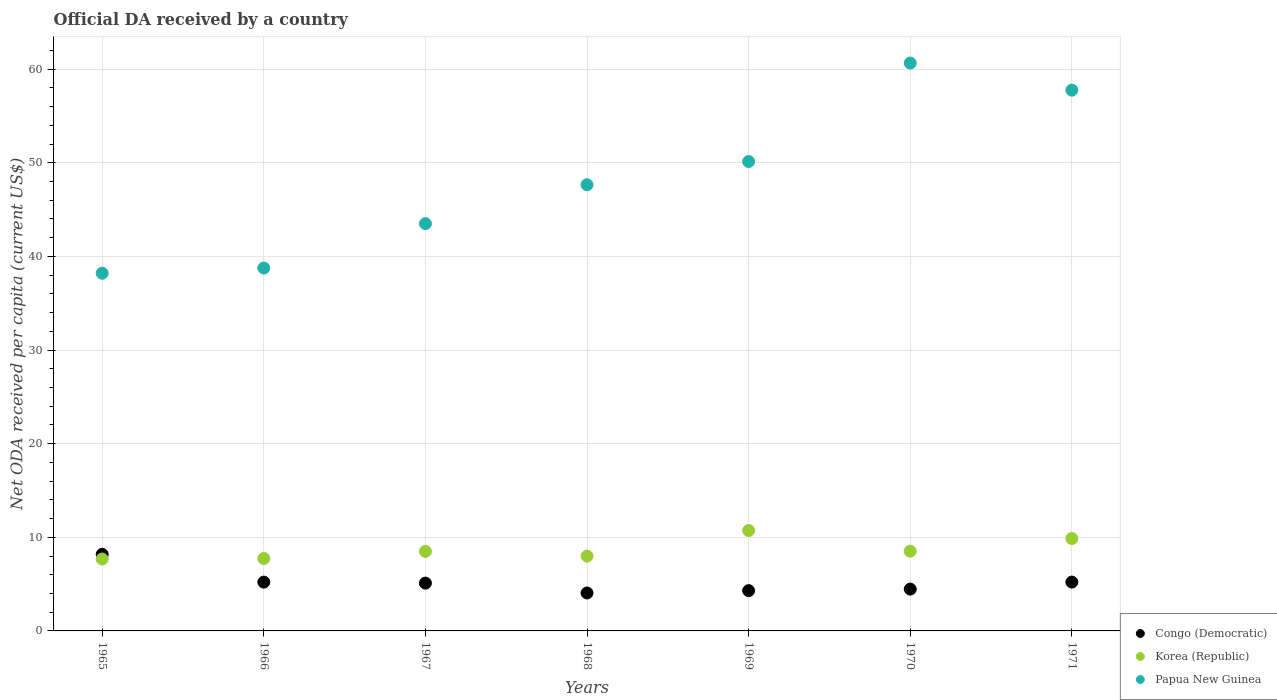How many different coloured dotlines are there?
Provide a succinct answer. 3. Is the number of dotlines equal to the number of legend labels?
Keep it short and to the point. Yes. What is the ODA received in in Congo (Democratic) in 1970?
Make the answer very short. 4.47. Across all years, what is the maximum ODA received in in Papua New Guinea?
Offer a very short reply. 60.65. Across all years, what is the minimum ODA received in in Congo (Democratic)?
Give a very brief answer. 4.05. In which year was the ODA received in in Korea (Republic) maximum?
Give a very brief answer. 1969. In which year was the ODA received in in Congo (Democratic) minimum?
Make the answer very short. 1968. What is the total ODA received in in Congo (Democratic) in the graph?
Your response must be concise. 36.54. What is the difference between the ODA received in in Congo (Democratic) in 1965 and that in 1969?
Offer a terse response. 3.88. What is the difference between the ODA received in in Papua New Guinea in 1971 and the ODA received in in Congo (Democratic) in 1970?
Your answer should be very brief. 53.29. What is the average ODA received in in Korea (Republic) per year?
Keep it short and to the point. 8.72. In the year 1968, what is the difference between the ODA received in in Papua New Guinea and ODA received in in Korea (Republic)?
Offer a very short reply. 39.66. In how many years, is the ODA received in in Papua New Guinea greater than 60 US$?
Your answer should be very brief. 1. What is the ratio of the ODA received in in Korea (Republic) in 1968 to that in 1969?
Your answer should be compact. 0.75. Is the ODA received in in Korea (Republic) in 1965 less than that in 1971?
Give a very brief answer. Yes. What is the difference between the highest and the second highest ODA received in in Congo (Democratic)?
Your answer should be compact. 2.96. What is the difference between the highest and the lowest ODA received in in Congo (Democratic)?
Provide a short and direct response. 4.13. Is the sum of the ODA received in in Papua New Guinea in 1965 and 1968 greater than the maximum ODA received in in Congo (Democratic) across all years?
Your response must be concise. Yes. Is the ODA received in in Korea (Republic) strictly greater than the ODA received in in Congo (Democratic) over the years?
Give a very brief answer. No. Is the ODA received in in Congo (Democratic) strictly less than the ODA received in in Korea (Republic) over the years?
Provide a short and direct response. No. Does the graph contain any zero values?
Provide a succinct answer. No. Does the graph contain grids?
Ensure brevity in your answer.  Yes. Where does the legend appear in the graph?
Keep it short and to the point. Bottom right. How many legend labels are there?
Your answer should be very brief. 3. How are the legend labels stacked?
Your answer should be compact. Vertical. What is the title of the graph?
Make the answer very short. Official DA received by a country. What is the label or title of the Y-axis?
Your response must be concise. Net ODA received per capita (current US$). What is the Net ODA received per capita (current US$) of Congo (Democratic) in 1965?
Offer a terse response. 8.18. What is the Net ODA received per capita (current US$) in Korea (Republic) in 1965?
Your answer should be very brief. 7.68. What is the Net ODA received per capita (current US$) in Papua New Guinea in 1965?
Provide a short and direct response. 38.2. What is the Net ODA received per capita (current US$) in Congo (Democratic) in 1966?
Ensure brevity in your answer.  5.21. What is the Net ODA received per capita (current US$) in Korea (Republic) in 1966?
Your response must be concise. 7.73. What is the Net ODA received per capita (current US$) in Papua New Guinea in 1966?
Your answer should be very brief. 38.76. What is the Net ODA received per capita (current US$) of Congo (Democratic) in 1967?
Ensure brevity in your answer.  5.1. What is the Net ODA received per capita (current US$) in Korea (Republic) in 1967?
Ensure brevity in your answer.  8.5. What is the Net ODA received per capita (current US$) in Papua New Guinea in 1967?
Your answer should be very brief. 43.5. What is the Net ODA received per capita (current US$) of Congo (Democratic) in 1968?
Provide a succinct answer. 4.05. What is the Net ODA received per capita (current US$) of Korea (Republic) in 1968?
Give a very brief answer. 7.99. What is the Net ODA received per capita (current US$) in Papua New Guinea in 1968?
Make the answer very short. 47.65. What is the Net ODA received per capita (current US$) in Congo (Democratic) in 1969?
Provide a short and direct response. 4.3. What is the Net ODA received per capita (current US$) of Korea (Republic) in 1969?
Give a very brief answer. 10.72. What is the Net ODA received per capita (current US$) in Papua New Guinea in 1969?
Give a very brief answer. 50.13. What is the Net ODA received per capita (current US$) in Congo (Democratic) in 1970?
Keep it short and to the point. 4.47. What is the Net ODA received per capita (current US$) in Korea (Republic) in 1970?
Offer a terse response. 8.52. What is the Net ODA received per capita (current US$) in Papua New Guinea in 1970?
Ensure brevity in your answer.  60.65. What is the Net ODA received per capita (current US$) of Congo (Democratic) in 1971?
Your answer should be compact. 5.22. What is the Net ODA received per capita (current US$) in Korea (Republic) in 1971?
Provide a short and direct response. 9.87. What is the Net ODA received per capita (current US$) in Papua New Guinea in 1971?
Your answer should be very brief. 57.75. Across all years, what is the maximum Net ODA received per capita (current US$) in Congo (Democratic)?
Offer a terse response. 8.18. Across all years, what is the maximum Net ODA received per capita (current US$) of Korea (Republic)?
Make the answer very short. 10.72. Across all years, what is the maximum Net ODA received per capita (current US$) of Papua New Guinea?
Your answer should be very brief. 60.65. Across all years, what is the minimum Net ODA received per capita (current US$) of Congo (Democratic)?
Provide a short and direct response. 4.05. Across all years, what is the minimum Net ODA received per capita (current US$) of Korea (Republic)?
Offer a very short reply. 7.68. Across all years, what is the minimum Net ODA received per capita (current US$) of Papua New Guinea?
Make the answer very short. 38.2. What is the total Net ODA received per capita (current US$) of Congo (Democratic) in the graph?
Offer a very short reply. 36.54. What is the total Net ODA received per capita (current US$) of Korea (Republic) in the graph?
Your answer should be compact. 61.02. What is the total Net ODA received per capita (current US$) of Papua New Guinea in the graph?
Ensure brevity in your answer.  336.64. What is the difference between the Net ODA received per capita (current US$) in Congo (Democratic) in 1965 and that in 1966?
Keep it short and to the point. 2.97. What is the difference between the Net ODA received per capita (current US$) in Korea (Republic) in 1965 and that in 1966?
Ensure brevity in your answer.  -0.05. What is the difference between the Net ODA received per capita (current US$) in Papua New Guinea in 1965 and that in 1966?
Your answer should be very brief. -0.55. What is the difference between the Net ODA received per capita (current US$) in Congo (Democratic) in 1965 and that in 1967?
Your answer should be compact. 3.08. What is the difference between the Net ODA received per capita (current US$) of Korea (Republic) in 1965 and that in 1967?
Provide a succinct answer. -0.82. What is the difference between the Net ODA received per capita (current US$) in Papua New Guinea in 1965 and that in 1967?
Give a very brief answer. -5.3. What is the difference between the Net ODA received per capita (current US$) of Congo (Democratic) in 1965 and that in 1968?
Give a very brief answer. 4.13. What is the difference between the Net ODA received per capita (current US$) of Korea (Republic) in 1965 and that in 1968?
Give a very brief answer. -0.31. What is the difference between the Net ODA received per capita (current US$) of Papua New Guinea in 1965 and that in 1968?
Your answer should be very brief. -9.45. What is the difference between the Net ODA received per capita (current US$) in Congo (Democratic) in 1965 and that in 1969?
Ensure brevity in your answer.  3.88. What is the difference between the Net ODA received per capita (current US$) in Korea (Republic) in 1965 and that in 1969?
Give a very brief answer. -3.04. What is the difference between the Net ODA received per capita (current US$) of Papua New Guinea in 1965 and that in 1969?
Offer a very short reply. -11.93. What is the difference between the Net ODA received per capita (current US$) of Congo (Democratic) in 1965 and that in 1970?
Your answer should be compact. 3.71. What is the difference between the Net ODA received per capita (current US$) of Korea (Republic) in 1965 and that in 1970?
Offer a very short reply. -0.84. What is the difference between the Net ODA received per capita (current US$) in Papua New Guinea in 1965 and that in 1970?
Your answer should be compact. -22.44. What is the difference between the Net ODA received per capita (current US$) of Congo (Democratic) in 1965 and that in 1971?
Provide a short and direct response. 2.96. What is the difference between the Net ODA received per capita (current US$) in Korea (Republic) in 1965 and that in 1971?
Provide a short and direct response. -2.19. What is the difference between the Net ODA received per capita (current US$) of Papua New Guinea in 1965 and that in 1971?
Offer a terse response. -19.55. What is the difference between the Net ODA received per capita (current US$) of Congo (Democratic) in 1966 and that in 1967?
Your response must be concise. 0.11. What is the difference between the Net ODA received per capita (current US$) in Korea (Republic) in 1966 and that in 1967?
Your answer should be compact. -0.77. What is the difference between the Net ODA received per capita (current US$) of Papua New Guinea in 1966 and that in 1967?
Offer a terse response. -4.74. What is the difference between the Net ODA received per capita (current US$) in Congo (Democratic) in 1966 and that in 1968?
Provide a succinct answer. 1.16. What is the difference between the Net ODA received per capita (current US$) of Korea (Republic) in 1966 and that in 1968?
Give a very brief answer. -0.26. What is the difference between the Net ODA received per capita (current US$) of Papua New Guinea in 1966 and that in 1968?
Provide a short and direct response. -8.9. What is the difference between the Net ODA received per capita (current US$) in Congo (Democratic) in 1966 and that in 1969?
Offer a terse response. 0.91. What is the difference between the Net ODA received per capita (current US$) of Korea (Republic) in 1966 and that in 1969?
Offer a very short reply. -2.99. What is the difference between the Net ODA received per capita (current US$) of Papua New Guinea in 1966 and that in 1969?
Your answer should be very brief. -11.38. What is the difference between the Net ODA received per capita (current US$) of Congo (Democratic) in 1966 and that in 1970?
Give a very brief answer. 0.75. What is the difference between the Net ODA received per capita (current US$) of Korea (Republic) in 1966 and that in 1970?
Ensure brevity in your answer.  -0.79. What is the difference between the Net ODA received per capita (current US$) of Papua New Guinea in 1966 and that in 1970?
Provide a succinct answer. -21.89. What is the difference between the Net ODA received per capita (current US$) in Congo (Democratic) in 1966 and that in 1971?
Provide a short and direct response. -0. What is the difference between the Net ODA received per capita (current US$) in Korea (Republic) in 1966 and that in 1971?
Your answer should be very brief. -2.14. What is the difference between the Net ODA received per capita (current US$) in Papua New Guinea in 1966 and that in 1971?
Your answer should be very brief. -19. What is the difference between the Net ODA received per capita (current US$) in Congo (Democratic) in 1967 and that in 1968?
Provide a short and direct response. 1.05. What is the difference between the Net ODA received per capita (current US$) in Korea (Republic) in 1967 and that in 1968?
Your answer should be very brief. 0.51. What is the difference between the Net ODA received per capita (current US$) in Papua New Guinea in 1967 and that in 1968?
Give a very brief answer. -4.15. What is the difference between the Net ODA received per capita (current US$) of Congo (Democratic) in 1967 and that in 1969?
Your response must be concise. 0.8. What is the difference between the Net ODA received per capita (current US$) of Korea (Republic) in 1967 and that in 1969?
Keep it short and to the point. -2.23. What is the difference between the Net ODA received per capita (current US$) in Papua New Guinea in 1967 and that in 1969?
Offer a very short reply. -6.63. What is the difference between the Net ODA received per capita (current US$) of Congo (Democratic) in 1967 and that in 1970?
Give a very brief answer. 0.64. What is the difference between the Net ODA received per capita (current US$) in Korea (Republic) in 1967 and that in 1970?
Offer a very short reply. -0.02. What is the difference between the Net ODA received per capita (current US$) of Papua New Guinea in 1967 and that in 1970?
Give a very brief answer. -17.15. What is the difference between the Net ODA received per capita (current US$) in Congo (Democratic) in 1967 and that in 1971?
Offer a very short reply. -0.11. What is the difference between the Net ODA received per capita (current US$) in Korea (Republic) in 1967 and that in 1971?
Your answer should be very brief. -1.37. What is the difference between the Net ODA received per capita (current US$) of Papua New Guinea in 1967 and that in 1971?
Offer a very short reply. -14.25. What is the difference between the Net ODA received per capita (current US$) in Congo (Democratic) in 1968 and that in 1969?
Your response must be concise. -0.25. What is the difference between the Net ODA received per capita (current US$) in Korea (Republic) in 1968 and that in 1969?
Offer a terse response. -2.73. What is the difference between the Net ODA received per capita (current US$) of Papua New Guinea in 1968 and that in 1969?
Give a very brief answer. -2.48. What is the difference between the Net ODA received per capita (current US$) in Congo (Democratic) in 1968 and that in 1970?
Offer a very short reply. -0.41. What is the difference between the Net ODA received per capita (current US$) of Korea (Republic) in 1968 and that in 1970?
Give a very brief answer. -0.53. What is the difference between the Net ODA received per capita (current US$) of Papua New Guinea in 1968 and that in 1970?
Your answer should be compact. -12.99. What is the difference between the Net ODA received per capita (current US$) in Congo (Democratic) in 1968 and that in 1971?
Your answer should be very brief. -1.16. What is the difference between the Net ODA received per capita (current US$) of Korea (Republic) in 1968 and that in 1971?
Your answer should be compact. -1.88. What is the difference between the Net ODA received per capita (current US$) in Papua New Guinea in 1968 and that in 1971?
Provide a succinct answer. -10.1. What is the difference between the Net ODA received per capita (current US$) of Congo (Democratic) in 1969 and that in 1970?
Offer a terse response. -0.16. What is the difference between the Net ODA received per capita (current US$) of Korea (Republic) in 1969 and that in 1970?
Your answer should be compact. 2.21. What is the difference between the Net ODA received per capita (current US$) in Papua New Guinea in 1969 and that in 1970?
Your answer should be compact. -10.51. What is the difference between the Net ODA received per capita (current US$) of Congo (Democratic) in 1969 and that in 1971?
Keep it short and to the point. -0.91. What is the difference between the Net ODA received per capita (current US$) of Korea (Republic) in 1969 and that in 1971?
Provide a succinct answer. 0.86. What is the difference between the Net ODA received per capita (current US$) in Papua New Guinea in 1969 and that in 1971?
Keep it short and to the point. -7.62. What is the difference between the Net ODA received per capita (current US$) of Congo (Democratic) in 1970 and that in 1971?
Provide a short and direct response. -0.75. What is the difference between the Net ODA received per capita (current US$) in Korea (Republic) in 1970 and that in 1971?
Provide a short and direct response. -1.35. What is the difference between the Net ODA received per capita (current US$) in Papua New Guinea in 1970 and that in 1971?
Keep it short and to the point. 2.89. What is the difference between the Net ODA received per capita (current US$) in Congo (Democratic) in 1965 and the Net ODA received per capita (current US$) in Korea (Republic) in 1966?
Your response must be concise. 0.45. What is the difference between the Net ODA received per capita (current US$) of Congo (Democratic) in 1965 and the Net ODA received per capita (current US$) of Papua New Guinea in 1966?
Your answer should be very brief. -30.58. What is the difference between the Net ODA received per capita (current US$) of Korea (Republic) in 1965 and the Net ODA received per capita (current US$) of Papua New Guinea in 1966?
Make the answer very short. -31.07. What is the difference between the Net ODA received per capita (current US$) of Congo (Democratic) in 1965 and the Net ODA received per capita (current US$) of Korea (Republic) in 1967?
Offer a very short reply. -0.32. What is the difference between the Net ODA received per capita (current US$) in Congo (Democratic) in 1965 and the Net ODA received per capita (current US$) in Papua New Guinea in 1967?
Offer a terse response. -35.32. What is the difference between the Net ODA received per capita (current US$) of Korea (Republic) in 1965 and the Net ODA received per capita (current US$) of Papua New Guinea in 1967?
Keep it short and to the point. -35.82. What is the difference between the Net ODA received per capita (current US$) in Congo (Democratic) in 1965 and the Net ODA received per capita (current US$) in Korea (Republic) in 1968?
Make the answer very short. 0.19. What is the difference between the Net ODA received per capita (current US$) in Congo (Democratic) in 1965 and the Net ODA received per capita (current US$) in Papua New Guinea in 1968?
Your response must be concise. -39.47. What is the difference between the Net ODA received per capita (current US$) in Korea (Republic) in 1965 and the Net ODA received per capita (current US$) in Papua New Guinea in 1968?
Your answer should be compact. -39.97. What is the difference between the Net ODA received per capita (current US$) in Congo (Democratic) in 1965 and the Net ODA received per capita (current US$) in Korea (Republic) in 1969?
Your answer should be very brief. -2.55. What is the difference between the Net ODA received per capita (current US$) in Congo (Democratic) in 1965 and the Net ODA received per capita (current US$) in Papua New Guinea in 1969?
Keep it short and to the point. -41.95. What is the difference between the Net ODA received per capita (current US$) in Korea (Republic) in 1965 and the Net ODA received per capita (current US$) in Papua New Guinea in 1969?
Your response must be concise. -42.45. What is the difference between the Net ODA received per capita (current US$) of Congo (Democratic) in 1965 and the Net ODA received per capita (current US$) of Korea (Republic) in 1970?
Your answer should be very brief. -0.34. What is the difference between the Net ODA received per capita (current US$) in Congo (Democratic) in 1965 and the Net ODA received per capita (current US$) in Papua New Guinea in 1970?
Offer a terse response. -52.47. What is the difference between the Net ODA received per capita (current US$) in Korea (Republic) in 1965 and the Net ODA received per capita (current US$) in Papua New Guinea in 1970?
Your response must be concise. -52.97. What is the difference between the Net ODA received per capita (current US$) of Congo (Democratic) in 1965 and the Net ODA received per capita (current US$) of Korea (Republic) in 1971?
Your answer should be compact. -1.69. What is the difference between the Net ODA received per capita (current US$) in Congo (Democratic) in 1965 and the Net ODA received per capita (current US$) in Papua New Guinea in 1971?
Offer a terse response. -49.57. What is the difference between the Net ODA received per capita (current US$) of Korea (Republic) in 1965 and the Net ODA received per capita (current US$) of Papua New Guinea in 1971?
Offer a terse response. -50.07. What is the difference between the Net ODA received per capita (current US$) of Congo (Democratic) in 1966 and the Net ODA received per capita (current US$) of Korea (Republic) in 1967?
Give a very brief answer. -3.29. What is the difference between the Net ODA received per capita (current US$) of Congo (Democratic) in 1966 and the Net ODA received per capita (current US$) of Papua New Guinea in 1967?
Your answer should be very brief. -38.29. What is the difference between the Net ODA received per capita (current US$) of Korea (Republic) in 1966 and the Net ODA received per capita (current US$) of Papua New Guinea in 1967?
Offer a terse response. -35.77. What is the difference between the Net ODA received per capita (current US$) of Congo (Democratic) in 1966 and the Net ODA received per capita (current US$) of Korea (Republic) in 1968?
Make the answer very short. -2.78. What is the difference between the Net ODA received per capita (current US$) in Congo (Democratic) in 1966 and the Net ODA received per capita (current US$) in Papua New Guinea in 1968?
Provide a short and direct response. -42.44. What is the difference between the Net ODA received per capita (current US$) in Korea (Republic) in 1966 and the Net ODA received per capita (current US$) in Papua New Guinea in 1968?
Make the answer very short. -39.92. What is the difference between the Net ODA received per capita (current US$) of Congo (Democratic) in 1966 and the Net ODA received per capita (current US$) of Korea (Republic) in 1969?
Make the answer very short. -5.51. What is the difference between the Net ODA received per capita (current US$) in Congo (Democratic) in 1966 and the Net ODA received per capita (current US$) in Papua New Guinea in 1969?
Your response must be concise. -44.92. What is the difference between the Net ODA received per capita (current US$) of Korea (Republic) in 1966 and the Net ODA received per capita (current US$) of Papua New Guinea in 1969?
Provide a succinct answer. -42.4. What is the difference between the Net ODA received per capita (current US$) of Congo (Democratic) in 1966 and the Net ODA received per capita (current US$) of Korea (Republic) in 1970?
Your answer should be very brief. -3.31. What is the difference between the Net ODA received per capita (current US$) of Congo (Democratic) in 1966 and the Net ODA received per capita (current US$) of Papua New Guinea in 1970?
Provide a short and direct response. -55.43. What is the difference between the Net ODA received per capita (current US$) in Korea (Republic) in 1966 and the Net ODA received per capita (current US$) in Papua New Guinea in 1970?
Your answer should be very brief. -52.91. What is the difference between the Net ODA received per capita (current US$) of Congo (Democratic) in 1966 and the Net ODA received per capita (current US$) of Korea (Republic) in 1971?
Your response must be concise. -4.66. What is the difference between the Net ODA received per capita (current US$) in Congo (Democratic) in 1966 and the Net ODA received per capita (current US$) in Papua New Guinea in 1971?
Provide a succinct answer. -52.54. What is the difference between the Net ODA received per capita (current US$) of Korea (Republic) in 1966 and the Net ODA received per capita (current US$) of Papua New Guinea in 1971?
Ensure brevity in your answer.  -50.02. What is the difference between the Net ODA received per capita (current US$) in Congo (Democratic) in 1967 and the Net ODA received per capita (current US$) in Korea (Republic) in 1968?
Provide a short and direct response. -2.89. What is the difference between the Net ODA received per capita (current US$) of Congo (Democratic) in 1967 and the Net ODA received per capita (current US$) of Papua New Guinea in 1968?
Keep it short and to the point. -42.55. What is the difference between the Net ODA received per capita (current US$) of Korea (Republic) in 1967 and the Net ODA received per capita (current US$) of Papua New Guinea in 1968?
Ensure brevity in your answer.  -39.15. What is the difference between the Net ODA received per capita (current US$) in Congo (Democratic) in 1967 and the Net ODA received per capita (current US$) in Korea (Republic) in 1969?
Your response must be concise. -5.62. What is the difference between the Net ODA received per capita (current US$) of Congo (Democratic) in 1967 and the Net ODA received per capita (current US$) of Papua New Guinea in 1969?
Offer a terse response. -45.03. What is the difference between the Net ODA received per capita (current US$) in Korea (Republic) in 1967 and the Net ODA received per capita (current US$) in Papua New Guinea in 1969?
Your answer should be compact. -41.63. What is the difference between the Net ODA received per capita (current US$) in Congo (Democratic) in 1967 and the Net ODA received per capita (current US$) in Korea (Republic) in 1970?
Your answer should be compact. -3.42. What is the difference between the Net ODA received per capita (current US$) in Congo (Democratic) in 1967 and the Net ODA received per capita (current US$) in Papua New Guinea in 1970?
Your answer should be compact. -55.54. What is the difference between the Net ODA received per capita (current US$) in Korea (Republic) in 1967 and the Net ODA received per capita (current US$) in Papua New Guinea in 1970?
Your response must be concise. -52.15. What is the difference between the Net ODA received per capita (current US$) of Congo (Democratic) in 1967 and the Net ODA received per capita (current US$) of Korea (Republic) in 1971?
Your answer should be compact. -4.76. What is the difference between the Net ODA received per capita (current US$) in Congo (Democratic) in 1967 and the Net ODA received per capita (current US$) in Papua New Guinea in 1971?
Your answer should be very brief. -52.65. What is the difference between the Net ODA received per capita (current US$) in Korea (Republic) in 1967 and the Net ODA received per capita (current US$) in Papua New Guinea in 1971?
Your response must be concise. -49.25. What is the difference between the Net ODA received per capita (current US$) in Congo (Democratic) in 1968 and the Net ODA received per capita (current US$) in Korea (Republic) in 1969?
Provide a short and direct response. -6.67. What is the difference between the Net ODA received per capita (current US$) of Congo (Democratic) in 1968 and the Net ODA received per capita (current US$) of Papua New Guinea in 1969?
Give a very brief answer. -46.08. What is the difference between the Net ODA received per capita (current US$) of Korea (Republic) in 1968 and the Net ODA received per capita (current US$) of Papua New Guinea in 1969?
Offer a very short reply. -42.14. What is the difference between the Net ODA received per capita (current US$) of Congo (Democratic) in 1968 and the Net ODA received per capita (current US$) of Korea (Republic) in 1970?
Provide a short and direct response. -4.47. What is the difference between the Net ODA received per capita (current US$) in Congo (Democratic) in 1968 and the Net ODA received per capita (current US$) in Papua New Guinea in 1970?
Make the answer very short. -56.59. What is the difference between the Net ODA received per capita (current US$) of Korea (Republic) in 1968 and the Net ODA received per capita (current US$) of Papua New Guinea in 1970?
Your response must be concise. -52.66. What is the difference between the Net ODA received per capita (current US$) in Congo (Democratic) in 1968 and the Net ODA received per capita (current US$) in Korea (Republic) in 1971?
Offer a terse response. -5.82. What is the difference between the Net ODA received per capita (current US$) in Congo (Democratic) in 1968 and the Net ODA received per capita (current US$) in Papua New Guinea in 1971?
Keep it short and to the point. -53.7. What is the difference between the Net ODA received per capita (current US$) in Korea (Republic) in 1968 and the Net ODA received per capita (current US$) in Papua New Guinea in 1971?
Offer a very short reply. -49.76. What is the difference between the Net ODA received per capita (current US$) in Congo (Democratic) in 1969 and the Net ODA received per capita (current US$) in Korea (Republic) in 1970?
Offer a terse response. -4.22. What is the difference between the Net ODA received per capita (current US$) in Congo (Democratic) in 1969 and the Net ODA received per capita (current US$) in Papua New Guinea in 1970?
Your answer should be compact. -56.34. What is the difference between the Net ODA received per capita (current US$) in Korea (Republic) in 1969 and the Net ODA received per capita (current US$) in Papua New Guinea in 1970?
Your response must be concise. -49.92. What is the difference between the Net ODA received per capita (current US$) in Congo (Democratic) in 1969 and the Net ODA received per capita (current US$) in Korea (Republic) in 1971?
Your answer should be very brief. -5.56. What is the difference between the Net ODA received per capita (current US$) of Congo (Democratic) in 1969 and the Net ODA received per capita (current US$) of Papua New Guinea in 1971?
Offer a terse response. -53.45. What is the difference between the Net ODA received per capita (current US$) in Korea (Republic) in 1969 and the Net ODA received per capita (current US$) in Papua New Guinea in 1971?
Your response must be concise. -47.03. What is the difference between the Net ODA received per capita (current US$) of Congo (Democratic) in 1970 and the Net ODA received per capita (current US$) of Korea (Republic) in 1971?
Offer a terse response. -5.4. What is the difference between the Net ODA received per capita (current US$) in Congo (Democratic) in 1970 and the Net ODA received per capita (current US$) in Papua New Guinea in 1971?
Provide a short and direct response. -53.29. What is the difference between the Net ODA received per capita (current US$) in Korea (Republic) in 1970 and the Net ODA received per capita (current US$) in Papua New Guinea in 1971?
Your answer should be compact. -49.23. What is the average Net ODA received per capita (current US$) of Congo (Democratic) per year?
Give a very brief answer. 5.22. What is the average Net ODA received per capita (current US$) of Korea (Republic) per year?
Ensure brevity in your answer.  8.72. What is the average Net ODA received per capita (current US$) in Papua New Guinea per year?
Provide a succinct answer. 48.09. In the year 1965, what is the difference between the Net ODA received per capita (current US$) in Congo (Democratic) and Net ODA received per capita (current US$) in Korea (Republic)?
Make the answer very short. 0.5. In the year 1965, what is the difference between the Net ODA received per capita (current US$) in Congo (Democratic) and Net ODA received per capita (current US$) in Papua New Guinea?
Offer a terse response. -30.02. In the year 1965, what is the difference between the Net ODA received per capita (current US$) of Korea (Republic) and Net ODA received per capita (current US$) of Papua New Guinea?
Keep it short and to the point. -30.52. In the year 1966, what is the difference between the Net ODA received per capita (current US$) in Congo (Democratic) and Net ODA received per capita (current US$) in Korea (Republic)?
Keep it short and to the point. -2.52. In the year 1966, what is the difference between the Net ODA received per capita (current US$) in Congo (Democratic) and Net ODA received per capita (current US$) in Papua New Guinea?
Offer a terse response. -33.54. In the year 1966, what is the difference between the Net ODA received per capita (current US$) in Korea (Republic) and Net ODA received per capita (current US$) in Papua New Guinea?
Provide a short and direct response. -31.02. In the year 1967, what is the difference between the Net ODA received per capita (current US$) in Congo (Democratic) and Net ODA received per capita (current US$) in Korea (Republic)?
Provide a succinct answer. -3.4. In the year 1967, what is the difference between the Net ODA received per capita (current US$) of Congo (Democratic) and Net ODA received per capita (current US$) of Papua New Guinea?
Ensure brevity in your answer.  -38.4. In the year 1967, what is the difference between the Net ODA received per capita (current US$) in Korea (Republic) and Net ODA received per capita (current US$) in Papua New Guinea?
Your response must be concise. -35. In the year 1968, what is the difference between the Net ODA received per capita (current US$) of Congo (Democratic) and Net ODA received per capita (current US$) of Korea (Republic)?
Offer a terse response. -3.94. In the year 1968, what is the difference between the Net ODA received per capita (current US$) of Congo (Democratic) and Net ODA received per capita (current US$) of Papua New Guinea?
Give a very brief answer. -43.6. In the year 1968, what is the difference between the Net ODA received per capita (current US$) of Korea (Republic) and Net ODA received per capita (current US$) of Papua New Guinea?
Give a very brief answer. -39.66. In the year 1969, what is the difference between the Net ODA received per capita (current US$) of Congo (Democratic) and Net ODA received per capita (current US$) of Korea (Republic)?
Offer a terse response. -6.42. In the year 1969, what is the difference between the Net ODA received per capita (current US$) in Congo (Democratic) and Net ODA received per capita (current US$) in Papua New Guinea?
Offer a very short reply. -45.83. In the year 1969, what is the difference between the Net ODA received per capita (current US$) of Korea (Republic) and Net ODA received per capita (current US$) of Papua New Guinea?
Offer a terse response. -39.41. In the year 1970, what is the difference between the Net ODA received per capita (current US$) in Congo (Democratic) and Net ODA received per capita (current US$) in Korea (Republic)?
Provide a succinct answer. -4.05. In the year 1970, what is the difference between the Net ODA received per capita (current US$) of Congo (Democratic) and Net ODA received per capita (current US$) of Papua New Guinea?
Ensure brevity in your answer.  -56.18. In the year 1970, what is the difference between the Net ODA received per capita (current US$) in Korea (Republic) and Net ODA received per capita (current US$) in Papua New Guinea?
Your answer should be very brief. -52.13. In the year 1971, what is the difference between the Net ODA received per capita (current US$) in Congo (Democratic) and Net ODA received per capita (current US$) in Korea (Republic)?
Offer a terse response. -4.65. In the year 1971, what is the difference between the Net ODA received per capita (current US$) in Congo (Democratic) and Net ODA received per capita (current US$) in Papua New Guinea?
Give a very brief answer. -52.54. In the year 1971, what is the difference between the Net ODA received per capita (current US$) in Korea (Republic) and Net ODA received per capita (current US$) in Papua New Guinea?
Your answer should be very brief. -47.88. What is the ratio of the Net ODA received per capita (current US$) in Congo (Democratic) in 1965 to that in 1966?
Your response must be concise. 1.57. What is the ratio of the Net ODA received per capita (current US$) of Korea (Republic) in 1965 to that in 1966?
Ensure brevity in your answer.  0.99. What is the ratio of the Net ODA received per capita (current US$) in Papua New Guinea in 1965 to that in 1966?
Offer a very short reply. 0.99. What is the ratio of the Net ODA received per capita (current US$) in Congo (Democratic) in 1965 to that in 1967?
Ensure brevity in your answer.  1.6. What is the ratio of the Net ODA received per capita (current US$) in Korea (Republic) in 1965 to that in 1967?
Your response must be concise. 0.9. What is the ratio of the Net ODA received per capita (current US$) in Papua New Guinea in 1965 to that in 1967?
Provide a short and direct response. 0.88. What is the ratio of the Net ODA received per capita (current US$) of Congo (Democratic) in 1965 to that in 1968?
Your answer should be compact. 2.02. What is the ratio of the Net ODA received per capita (current US$) in Korea (Republic) in 1965 to that in 1968?
Your response must be concise. 0.96. What is the ratio of the Net ODA received per capita (current US$) of Papua New Guinea in 1965 to that in 1968?
Offer a very short reply. 0.8. What is the ratio of the Net ODA received per capita (current US$) of Congo (Democratic) in 1965 to that in 1969?
Offer a terse response. 1.9. What is the ratio of the Net ODA received per capita (current US$) of Korea (Republic) in 1965 to that in 1969?
Your answer should be compact. 0.72. What is the ratio of the Net ODA received per capita (current US$) of Papua New Guinea in 1965 to that in 1969?
Keep it short and to the point. 0.76. What is the ratio of the Net ODA received per capita (current US$) of Congo (Democratic) in 1965 to that in 1970?
Your answer should be very brief. 1.83. What is the ratio of the Net ODA received per capita (current US$) in Korea (Republic) in 1965 to that in 1970?
Ensure brevity in your answer.  0.9. What is the ratio of the Net ODA received per capita (current US$) of Papua New Guinea in 1965 to that in 1970?
Your answer should be very brief. 0.63. What is the ratio of the Net ODA received per capita (current US$) of Congo (Democratic) in 1965 to that in 1971?
Keep it short and to the point. 1.57. What is the ratio of the Net ODA received per capita (current US$) in Korea (Republic) in 1965 to that in 1971?
Provide a succinct answer. 0.78. What is the ratio of the Net ODA received per capita (current US$) of Papua New Guinea in 1965 to that in 1971?
Offer a terse response. 0.66. What is the ratio of the Net ODA received per capita (current US$) in Congo (Democratic) in 1966 to that in 1967?
Provide a succinct answer. 1.02. What is the ratio of the Net ODA received per capita (current US$) of Korea (Republic) in 1966 to that in 1967?
Provide a short and direct response. 0.91. What is the ratio of the Net ODA received per capita (current US$) of Papua New Guinea in 1966 to that in 1967?
Provide a succinct answer. 0.89. What is the ratio of the Net ODA received per capita (current US$) in Congo (Democratic) in 1966 to that in 1968?
Provide a short and direct response. 1.29. What is the ratio of the Net ODA received per capita (current US$) of Papua New Guinea in 1966 to that in 1968?
Your response must be concise. 0.81. What is the ratio of the Net ODA received per capita (current US$) in Congo (Democratic) in 1966 to that in 1969?
Provide a short and direct response. 1.21. What is the ratio of the Net ODA received per capita (current US$) of Korea (Republic) in 1966 to that in 1969?
Your response must be concise. 0.72. What is the ratio of the Net ODA received per capita (current US$) in Papua New Guinea in 1966 to that in 1969?
Give a very brief answer. 0.77. What is the ratio of the Net ODA received per capita (current US$) in Congo (Democratic) in 1966 to that in 1970?
Your answer should be compact. 1.17. What is the ratio of the Net ODA received per capita (current US$) in Korea (Republic) in 1966 to that in 1970?
Keep it short and to the point. 0.91. What is the ratio of the Net ODA received per capita (current US$) of Papua New Guinea in 1966 to that in 1970?
Ensure brevity in your answer.  0.64. What is the ratio of the Net ODA received per capita (current US$) of Congo (Democratic) in 1966 to that in 1971?
Provide a succinct answer. 1. What is the ratio of the Net ODA received per capita (current US$) in Korea (Republic) in 1966 to that in 1971?
Ensure brevity in your answer.  0.78. What is the ratio of the Net ODA received per capita (current US$) of Papua New Guinea in 1966 to that in 1971?
Provide a short and direct response. 0.67. What is the ratio of the Net ODA received per capita (current US$) of Congo (Democratic) in 1967 to that in 1968?
Offer a very short reply. 1.26. What is the ratio of the Net ODA received per capita (current US$) of Korea (Republic) in 1967 to that in 1968?
Your response must be concise. 1.06. What is the ratio of the Net ODA received per capita (current US$) in Papua New Guinea in 1967 to that in 1968?
Ensure brevity in your answer.  0.91. What is the ratio of the Net ODA received per capita (current US$) in Congo (Democratic) in 1967 to that in 1969?
Provide a succinct answer. 1.19. What is the ratio of the Net ODA received per capita (current US$) of Korea (Republic) in 1967 to that in 1969?
Your answer should be compact. 0.79. What is the ratio of the Net ODA received per capita (current US$) of Papua New Guinea in 1967 to that in 1969?
Offer a very short reply. 0.87. What is the ratio of the Net ODA received per capita (current US$) in Korea (Republic) in 1967 to that in 1970?
Provide a succinct answer. 1. What is the ratio of the Net ODA received per capita (current US$) in Papua New Guinea in 1967 to that in 1970?
Make the answer very short. 0.72. What is the ratio of the Net ODA received per capita (current US$) in Congo (Democratic) in 1967 to that in 1971?
Your response must be concise. 0.98. What is the ratio of the Net ODA received per capita (current US$) in Korea (Republic) in 1967 to that in 1971?
Ensure brevity in your answer.  0.86. What is the ratio of the Net ODA received per capita (current US$) of Papua New Guinea in 1967 to that in 1971?
Your answer should be compact. 0.75. What is the ratio of the Net ODA received per capita (current US$) in Congo (Democratic) in 1968 to that in 1969?
Your response must be concise. 0.94. What is the ratio of the Net ODA received per capita (current US$) in Korea (Republic) in 1968 to that in 1969?
Provide a short and direct response. 0.75. What is the ratio of the Net ODA received per capita (current US$) in Papua New Guinea in 1968 to that in 1969?
Provide a succinct answer. 0.95. What is the ratio of the Net ODA received per capita (current US$) of Congo (Democratic) in 1968 to that in 1970?
Your response must be concise. 0.91. What is the ratio of the Net ODA received per capita (current US$) of Korea (Republic) in 1968 to that in 1970?
Keep it short and to the point. 0.94. What is the ratio of the Net ODA received per capita (current US$) in Papua New Guinea in 1968 to that in 1970?
Ensure brevity in your answer.  0.79. What is the ratio of the Net ODA received per capita (current US$) of Congo (Democratic) in 1968 to that in 1971?
Offer a terse response. 0.78. What is the ratio of the Net ODA received per capita (current US$) of Korea (Republic) in 1968 to that in 1971?
Offer a very short reply. 0.81. What is the ratio of the Net ODA received per capita (current US$) of Papua New Guinea in 1968 to that in 1971?
Offer a very short reply. 0.83. What is the ratio of the Net ODA received per capita (current US$) of Congo (Democratic) in 1969 to that in 1970?
Your response must be concise. 0.96. What is the ratio of the Net ODA received per capita (current US$) in Korea (Republic) in 1969 to that in 1970?
Offer a terse response. 1.26. What is the ratio of the Net ODA received per capita (current US$) of Papua New Guinea in 1969 to that in 1970?
Give a very brief answer. 0.83. What is the ratio of the Net ODA received per capita (current US$) of Congo (Democratic) in 1969 to that in 1971?
Your response must be concise. 0.82. What is the ratio of the Net ODA received per capita (current US$) of Korea (Republic) in 1969 to that in 1971?
Provide a short and direct response. 1.09. What is the ratio of the Net ODA received per capita (current US$) in Papua New Guinea in 1969 to that in 1971?
Your answer should be very brief. 0.87. What is the ratio of the Net ODA received per capita (current US$) in Congo (Democratic) in 1970 to that in 1971?
Give a very brief answer. 0.86. What is the ratio of the Net ODA received per capita (current US$) in Korea (Republic) in 1970 to that in 1971?
Provide a succinct answer. 0.86. What is the ratio of the Net ODA received per capita (current US$) in Papua New Guinea in 1970 to that in 1971?
Your response must be concise. 1.05. What is the difference between the highest and the second highest Net ODA received per capita (current US$) in Congo (Democratic)?
Provide a succinct answer. 2.96. What is the difference between the highest and the second highest Net ODA received per capita (current US$) in Korea (Republic)?
Offer a very short reply. 0.86. What is the difference between the highest and the second highest Net ODA received per capita (current US$) of Papua New Guinea?
Give a very brief answer. 2.89. What is the difference between the highest and the lowest Net ODA received per capita (current US$) of Congo (Democratic)?
Offer a very short reply. 4.13. What is the difference between the highest and the lowest Net ODA received per capita (current US$) of Korea (Republic)?
Offer a terse response. 3.04. What is the difference between the highest and the lowest Net ODA received per capita (current US$) in Papua New Guinea?
Offer a very short reply. 22.44. 